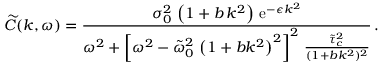Convert formula to latex. <formula><loc_0><loc_0><loc_500><loc_500>\widetilde { C } ( k , \omega ) = \frac { \sigma _ { 0 } ^ { 2 } \, \left ( 1 + b \, k ^ { 2 } \right ) \, e ^ { - \epsilon k ^ { 2 } } } { \omega ^ { 2 } + \left [ \omega ^ { 2 } - \tilde { \omega } _ { 0 } ^ { 2 } \, \left ( 1 + b k ^ { 2 } \right ) ^ { 2 } \right ] ^ { 2 } \, \frac { \tilde { \tau } _ { c } ^ { 2 } } { ( 1 + b k ^ { 2 } ) ^ { 2 } } } \, .</formula> 